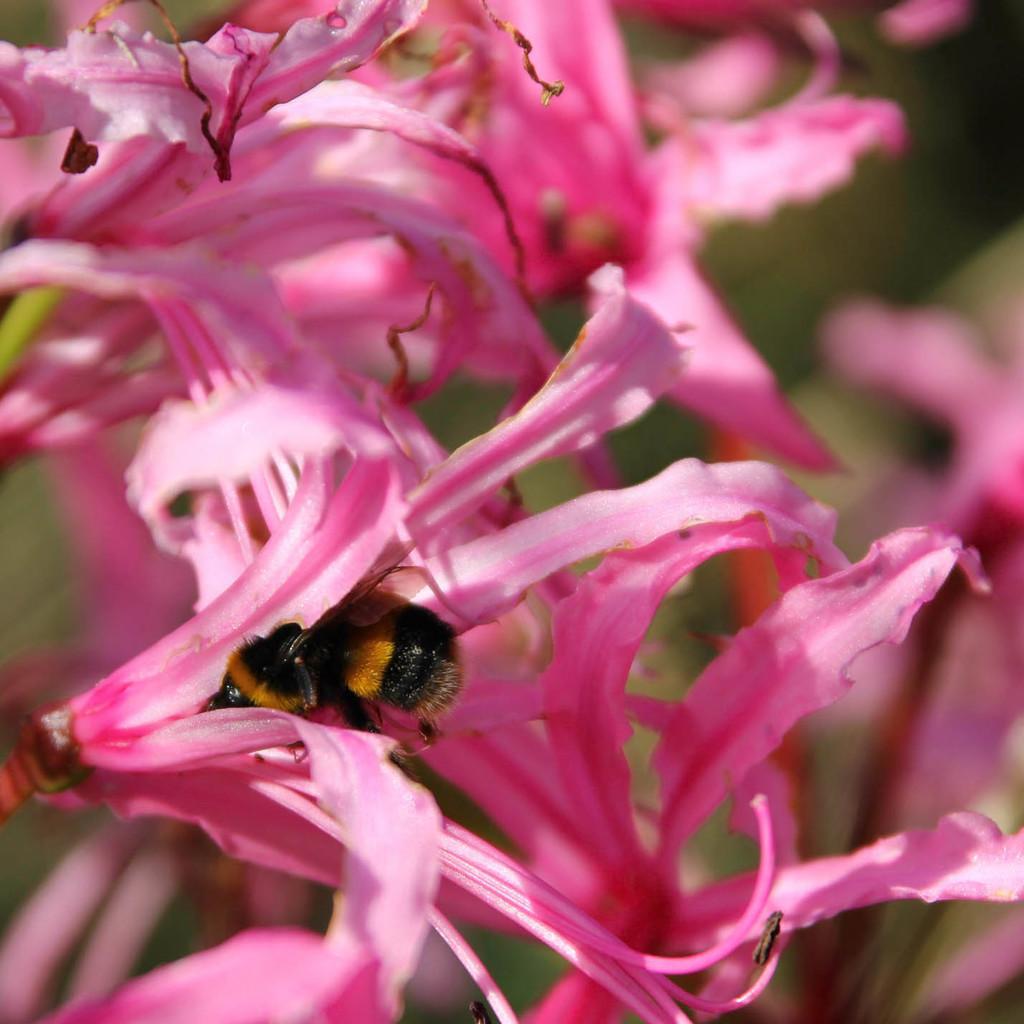Could you give a brief overview of what you see in this image? In this image there are flowers. There are pink petals to the flowers. There is a honey bee inside a flower. The background is blurry. 